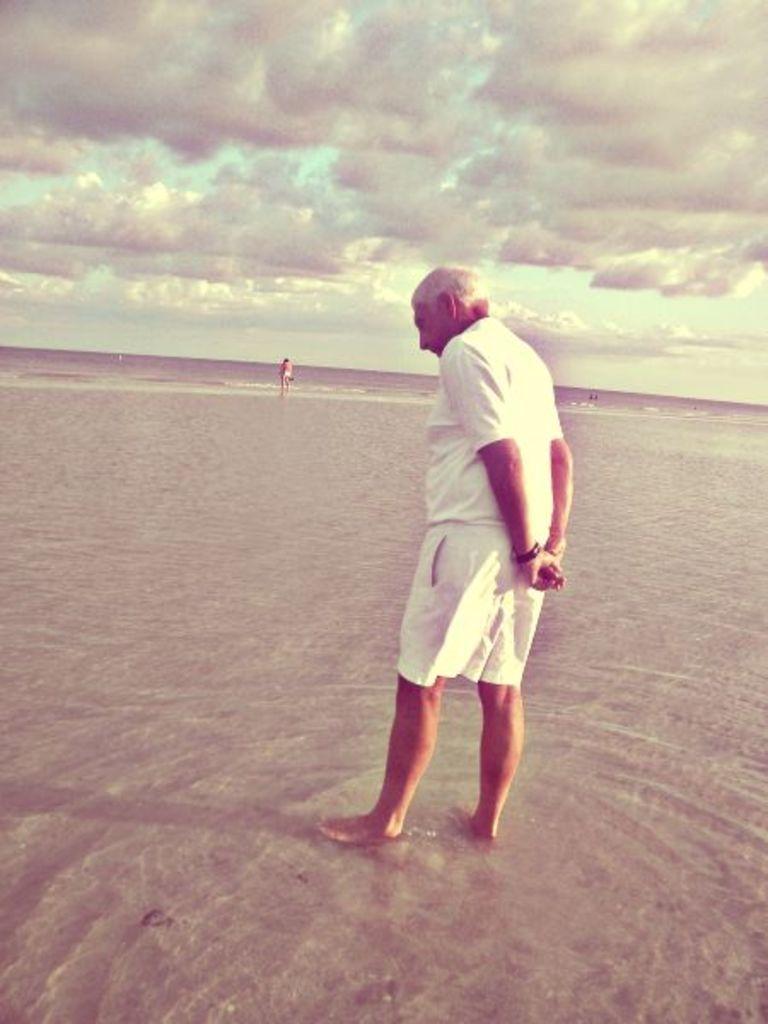Can you describe this image briefly? In this image in the foreground there is one person standing, and in the background there is another person. At the bottom there are some water, and in the background there is a beach. At the top there is sky. 